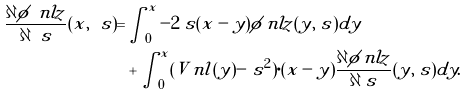Convert formula to latex. <formula><loc_0><loc_0><loc_500><loc_500>\frac { \partial \phi _ { \ } n l z } { \partial \ s } ( x , \ s ) = & \int _ { 0 } ^ { x } - 2 \ s ( x - y ) \phi _ { \ } n l z ( y , \ s ) d y \\ & + \int _ { 0 } ^ { x } ( V _ { \ } n l ( y ) - \ s ^ { 2 } ) \cdot ( x - y ) \frac { \partial \phi _ { \ } n l z } { \partial \ s } ( y , \ s ) d y .</formula> 